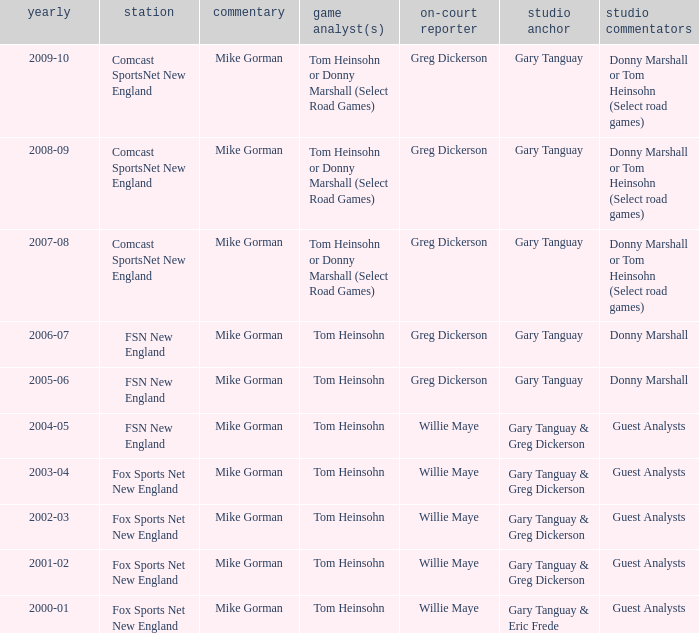WHich Play-by-play has a Studio host of gary tanguay, and a Studio analysts of donny marshall? Mike Gorman, Mike Gorman. 